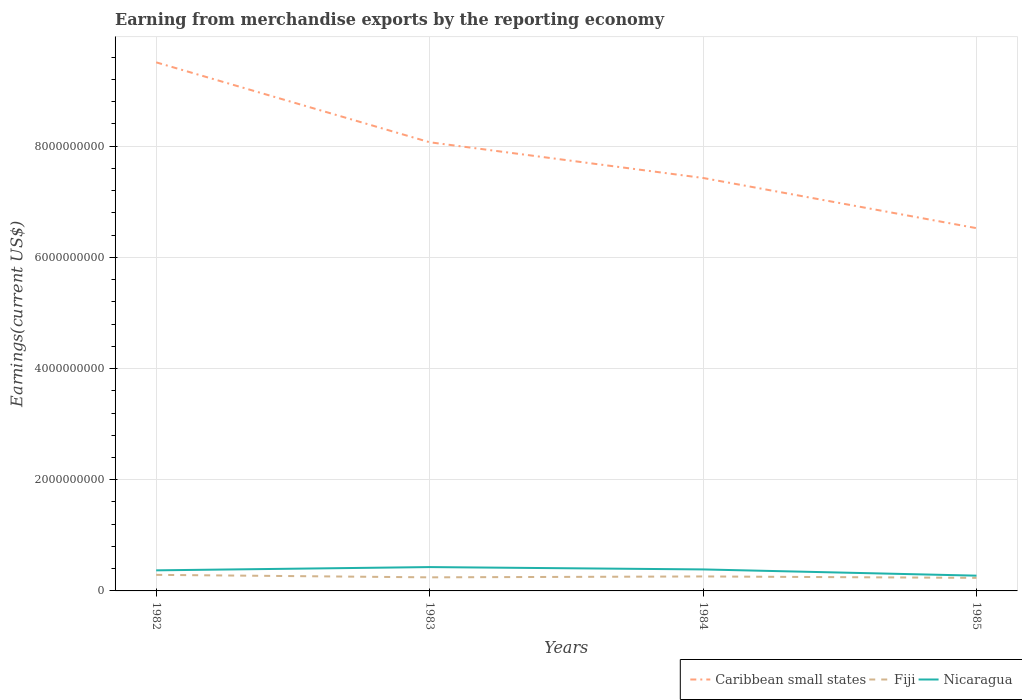How many different coloured lines are there?
Keep it short and to the point. 3. Does the line corresponding to Fiji intersect with the line corresponding to Nicaragua?
Keep it short and to the point. No. Across all years, what is the maximum amount earned from merchandise exports in Fiji?
Ensure brevity in your answer.  2.35e+08. What is the total amount earned from merchandise exports in Caribbean small states in the graph?
Give a very brief answer. 9.03e+08. What is the difference between the highest and the second highest amount earned from merchandise exports in Fiji?
Provide a short and direct response. 5.42e+07. How many lines are there?
Provide a succinct answer. 3. How many years are there in the graph?
Give a very brief answer. 4. How are the legend labels stacked?
Provide a succinct answer. Horizontal. What is the title of the graph?
Your answer should be very brief. Earning from merchandise exports by the reporting economy. Does "Indonesia" appear as one of the legend labels in the graph?
Provide a succinct answer. No. What is the label or title of the Y-axis?
Provide a short and direct response. Earnings(current US$). What is the Earnings(current US$) of Caribbean small states in 1982?
Provide a short and direct response. 9.51e+09. What is the Earnings(current US$) of Fiji in 1982?
Offer a terse response. 2.89e+08. What is the Earnings(current US$) of Nicaragua in 1982?
Make the answer very short. 3.70e+08. What is the Earnings(current US$) in Caribbean small states in 1983?
Your answer should be compact. 8.07e+09. What is the Earnings(current US$) in Fiji in 1983?
Make the answer very short. 2.44e+08. What is the Earnings(current US$) of Nicaragua in 1983?
Make the answer very short. 4.29e+08. What is the Earnings(current US$) in Caribbean small states in 1984?
Keep it short and to the point. 7.43e+09. What is the Earnings(current US$) in Fiji in 1984?
Your answer should be very brief. 2.60e+08. What is the Earnings(current US$) in Nicaragua in 1984?
Offer a terse response. 3.87e+08. What is the Earnings(current US$) of Caribbean small states in 1985?
Your answer should be compact. 6.53e+09. What is the Earnings(current US$) of Fiji in 1985?
Offer a terse response. 2.35e+08. What is the Earnings(current US$) of Nicaragua in 1985?
Your answer should be very brief. 2.75e+08. Across all years, what is the maximum Earnings(current US$) in Caribbean small states?
Ensure brevity in your answer.  9.51e+09. Across all years, what is the maximum Earnings(current US$) in Fiji?
Your answer should be very brief. 2.89e+08. Across all years, what is the maximum Earnings(current US$) of Nicaragua?
Offer a terse response. 4.29e+08. Across all years, what is the minimum Earnings(current US$) of Caribbean small states?
Provide a short and direct response. 6.53e+09. Across all years, what is the minimum Earnings(current US$) in Fiji?
Make the answer very short. 2.35e+08. Across all years, what is the minimum Earnings(current US$) of Nicaragua?
Give a very brief answer. 2.75e+08. What is the total Earnings(current US$) of Caribbean small states in the graph?
Ensure brevity in your answer.  3.15e+1. What is the total Earnings(current US$) in Fiji in the graph?
Provide a succinct answer. 1.03e+09. What is the total Earnings(current US$) of Nicaragua in the graph?
Provide a succinct answer. 1.46e+09. What is the difference between the Earnings(current US$) of Caribbean small states in 1982 and that in 1983?
Offer a terse response. 1.44e+09. What is the difference between the Earnings(current US$) in Fiji in 1982 and that in 1983?
Your answer should be very brief. 4.49e+07. What is the difference between the Earnings(current US$) in Nicaragua in 1982 and that in 1983?
Your answer should be compact. -5.86e+07. What is the difference between the Earnings(current US$) of Caribbean small states in 1982 and that in 1984?
Ensure brevity in your answer.  2.08e+09. What is the difference between the Earnings(current US$) of Fiji in 1982 and that in 1984?
Keep it short and to the point. 2.86e+07. What is the difference between the Earnings(current US$) of Nicaragua in 1982 and that in 1984?
Offer a terse response. -1.65e+07. What is the difference between the Earnings(current US$) of Caribbean small states in 1982 and that in 1985?
Provide a short and direct response. 2.98e+09. What is the difference between the Earnings(current US$) of Fiji in 1982 and that in 1985?
Offer a very short reply. 5.42e+07. What is the difference between the Earnings(current US$) of Nicaragua in 1982 and that in 1985?
Offer a very short reply. 9.56e+07. What is the difference between the Earnings(current US$) of Caribbean small states in 1983 and that in 1984?
Your response must be concise. 6.42e+08. What is the difference between the Earnings(current US$) of Fiji in 1983 and that in 1984?
Your answer should be compact. -1.62e+07. What is the difference between the Earnings(current US$) of Nicaragua in 1983 and that in 1984?
Provide a succinct answer. 4.21e+07. What is the difference between the Earnings(current US$) in Caribbean small states in 1983 and that in 1985?
Ensure brevity in your answer.  1.55e+09. What is the difference between the Earnings(current US$) of Fiji in 1983 and that in 1985?
Offer a terse response. 9.33e+06. What is the difference between the Earnings(current US$) of Nicaragua in 1983 and that in 1985?
Ensure brevity in your answer.  1.54e+08. What is the difference between the Earnings(current US$) of Caribbean small states in 1984 and that in 1985?
Offer a very short reply. 9.03e+08. What is the difference between the Earnings(current US$) of Fiji in 1984 and that in 1985?
Your answer should be compact. 2.56e+07. What is the difference between the Earnings(current US$) in Nicaragua in 1984 and that in 1985?
Provide a succinct answer. 1.12e+08. What is the difference between the Earnings(current US$) of Caribbean small states in 1982 and the Earnings(current US$) of Fiji in 1983?
Keep it short and to the point. 9.26e+09. What is the difference between the Earnings(current US$) in Caribbean small states in 1982 and the Earnings(current US$) in Nicaragua in 1983?
Give a very brief answer. 9.08e+09. What is the difference between the Earnings(current US$) of Fiji in 1982 and the Earnings(current US$) of Nicaragua in 1983?
Your answer should be very brief. -1.40e+08. What is the difference between the Earnings(current US$) in Caribbean small states in 1982 and the Earnings(current US$) in Fiji in 1984?
Your answer should be very brief. 9.25e+09. What is the difference between the Earnings(current US$) in Caribbean small states in 1982 and the Earnings(current US$) in Nicaragua in 1984?
Provide a short and direct response. 9.12e+09. What is the difference between the Earnings(current US$) of Fiji in 1982 and the Earnings(current US$) of Nicaragua in 1984?
Offer a very short reply. -9.76e+07. What is the difference between the Earnings(current US$) in Caribbean small states in 1982 and the Earnings(current US$) in Fiji in 1985?
Make the answer very short. 9.27e+09. What is the difference between the Earnings(current US$) of Caribbean small states in 1982 and the Earnings(current US$) of Nicaragua in 1985?
Your answer should be compact. 9.23e+09. What is the difference between the Earnings(current US$) of Fiji in 1982 and the Earnings(current US$) of Nicaragua in 1985?
Make the answer very short. 1.44e+07. What is the difference between the Earnings(current US$) in Caribbean small states in 1983 and the Earnings(current US$) in Fiji in 1984?
Give a very brief answer. 7.81e+09. What is the difference between the Earnings(current US$) of Caribbean small states in 1983 and the Earnings(current US$) of Nicaragua in 1984?
Provide a short and direct response. 7.68e+09. What is the difference between the Earnings(current US$) in Fiji in 1983 and the Earnings(current US$) in Nicaragua in 1984?
Provide a succinct answer. -1.42e+08. What is the difference between the Earnings(current US$) in Caribbean small states in 1983 and the Earnings(current US$) in Fiji in 1985?
Ensure brevity in your answer.  7.84e+09. What is the difference between the Earnings(current US$) of Caribbean small states in 1983 and the Earnings(current US$) of Nicaragua in 1985?
Your answer should be very brief. 7.80e+09. What is the difference between the Earnings(current US$) in Fiji in 1983 and the Earnings(current US$) in Nicaragua in 1985?
Your answer should be very brief. -3.04e+07. What is the difference between the Earnings(current US$) in Caribbean small states in 1984 and the Earnings(current US$) in Fiji in 1985?
Your answer should be compact. 7.19e+09. What is the difference between the Earnings(current US$) of Caribbean small states in 1984 and the Earnings(current US$) of Nicaragua in 1985?
Your response must be concise. 7.15e+09. What is the difference between the Earnings(current US$) of Fiji in 1984 and the Earnings(current US$) of Nicaragua in 1985?
Make the answer very short. -1.42e+07. What is the average Earnings(current US$) of Caribbean small states per year?
Keep it short and to the point. 7.88e+09. What is the average Earnings(current US$) in Fiji per year?
Give a very brief answer. 2.57e+08. What is the average Earnings(current US$) of Nicaragua per year?
Provide a succinct answer. 3.65e+08. In the year 1982, what is the difference between the Earnings(current US$) of Caribbean small states and Earnings(current US$) of Fiji?
Your answer should be very brief. 9.22e+09. In the year 1982, what is the difference between the Earnings(current US$) in Caribbean small states and Earnings(current US$) in Nicaragua?
Provide a short and direct response. 9.14e+09. In the year 1982, what is the difference between the Earnings(current US$) in Fiji and Earnings(current US$) in Nicaragua?
Provide a succinct answer. -8.11e+07. In the year 1983, what is the difference between the Earnings(current US$) in Caribbean small states and Earnings(current US$) in Fiji?
Your answer should be compact. 7.83e+09. In the year 1983, what is the difference between the Earnings(current US$) of Caribbean small states and Earnings(current US$) of Nicaragua?
Ensure brevity in your answer.  7.64e+09. In the year 1983, what is the difference between the Earnings(current US$) of Fiji and Earnings(current US$) of Nicaragua?
Ensure brevity in your answer.  -1.85e+08. In the year 1984, what is the difference between the Earnings(current US$) in Caribbean small states and Earnings(current US$) in Fiji?
Provide a succinct answer. 7.17e+09. In the year 1984, what is the difference between the Earnings(current US$) in Caribbean small states and Earnings(current US$) in Nicaragua?
Your answer should be very brief. 7.04e+09. In the year 1984, what is the difference between the Earnings(current US$) of Fiji and Earnings(current US$) of Nicaragua?
Ensure brevity in your answer.  -1.26e+08. In the year 1985, what is the difference between the Earnings(current US$) of Caribbean small states and Earnings(current US$) of Fiji?
Your response must be concise. 6.29e+09. In the year 1985, what is the difference between the Earnings(current US$) in Caribbean small states and Earnings(current US$) in Nicaragua?
Provide a short and direct response. 6.25e+09. In the year 1985, what is the difference between the Earnings(current US$) of Fiji and Earnings(current US$) of Nicaragua?
Offer a terse response. -3.97e+07. What is the ratio of the Earnings(current US$) in Caribbean small states in 1982 to that in 1983?
Provide a succinct answer. 1.18. What is the ratio of the Earnings(current US$) in Fiji in 1982 to that in 1983?
Give a very brief answer. 1.18. What is the ratio of the Earnings(current US$) of Nicaragua in 1982 to that in 1983?
Your answer should be compact. 0.86. What is the ratio of the Earnings(current US$) in Caribbean small states in 1982 to that in 1984?
Your response must be concise. 1.28. What is the ratio of the Earnings(current US$) of Fiji in 1982 to that in 1984?
Your answer should be very brief. 1.11. What is the ratio of the Earnings(current US$) in Nicaragua in 1982 to that in 1984?
Make the answer very short. 0.96. What is the ratio of the Earnings(current US$) of Caribbean small states in 1982 to that in 1985?
Keep it short and to the point. 1.46. What is the ratio of the Earnings(current US$) in Fiji in 1982 to that in 1985?
Ensure brevity in your answer.  1.23. What is the ratio of the Earnings(current US$) of Nicaragua in 1982 to that in 1985?
Your answer should be compact. 1.35. What is the ratio of the Earnings(current US$) in Caribbean small states in 1983 to that in 1984?
Keep it short and to the point. 1.09. What is the ratio of the Earnings(current US$) of Fiji in 1983 to that in 1984?
Provide a short and direct response. 0.94. What is the ratio of the Earnings(current US$) of Nicaragua in 1983 to that in 1984?
Keep it short and to the point. 1.11. What is the ratio of the Earnings(current US$) of Caribbean small states in 1983 to that in 1985?
Make the answer very short. 1.24. What is the ratio of the Earnings(current US$) in Fiji in 1983 to that in 1985?
Ensure brevity in your answer.  1.04. What is the ratio of the Earnings(current US$) in Nicaragua in 1983 to that in 1985?
Offer a terse response. 1.56. What is the ratio of the Earnings(current US$) in Caribbean small states in 1984 to that in 1985?
Provide a short and direct response. 1.14. What is the ratio of the Earnings(current US$) in Fiji in 1984 to that in 1985?
Offer a very short reply. 1.11. What is the ratio of the Earnings(current US$) in Nicaragua in 1984 to that in 1985?
Give a very brief answer. 1.41. What is the difference between the highest and the second highest Earnings(current US$) in Caribbean small states?
Give a very brief answer. 1.44e+09. What is the difference between the highest and the second highest Earnings(current US$) in Fiji?
Keep it short and to the point. 2.86e+07. What is the difference between the highest and the second highest Earnings(current US$) of Nicaragua?
Offer a terse response. 4.21e+07. What is the difference between the highest and the lowest Earnings(current US$) in Caribbean small states?
Keep it short and to the point. 2.98e+09. What is the difference between the highest and the lowest Earnings(current US$) in Fiji?
Your response must be concise. 5.42e+07. What is the difference between the highest and the lowest Earnings(current US$) of Nicaragua?
Make the answer very short. 1.54e+08. 